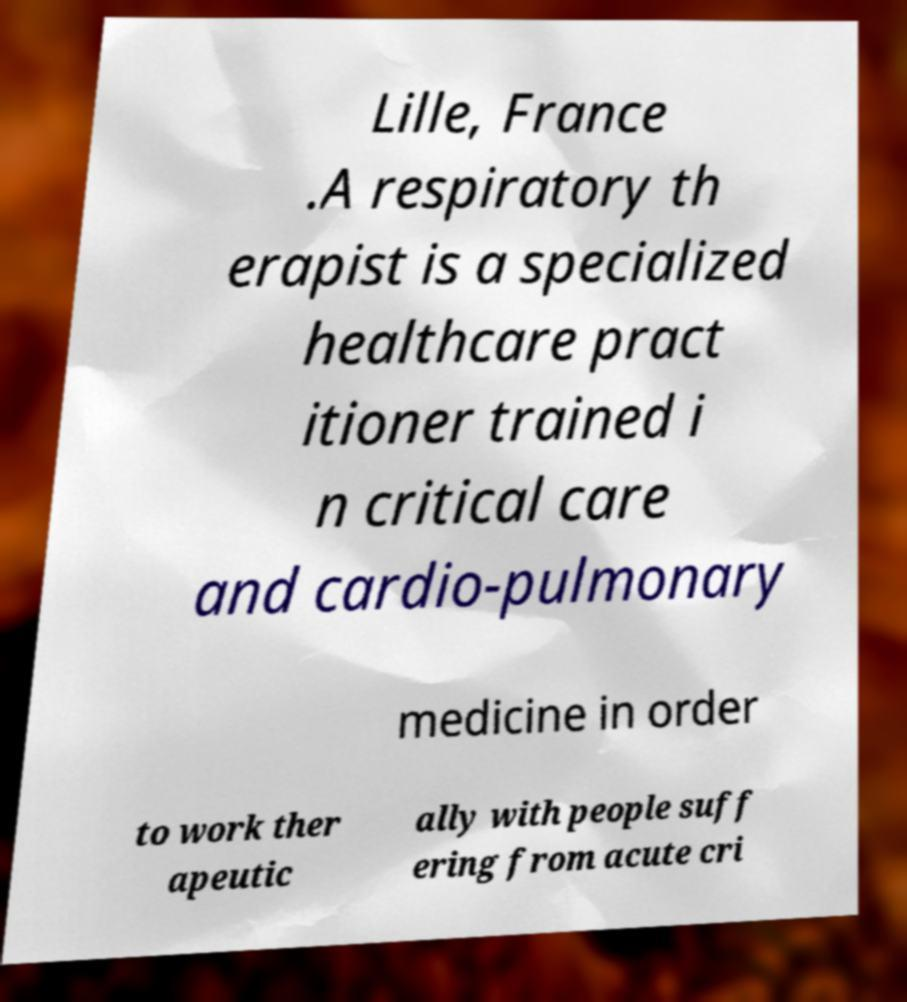There's text embedded in this image that I need extracted. Can you transcribe it verbatim? Lille, France .A respiratory th erapist is a specialized healthcare pract itioner trained i n critical care and cardio-pulmonary medicine in order to work ther apeutic ally with people suff ering from acute cri 